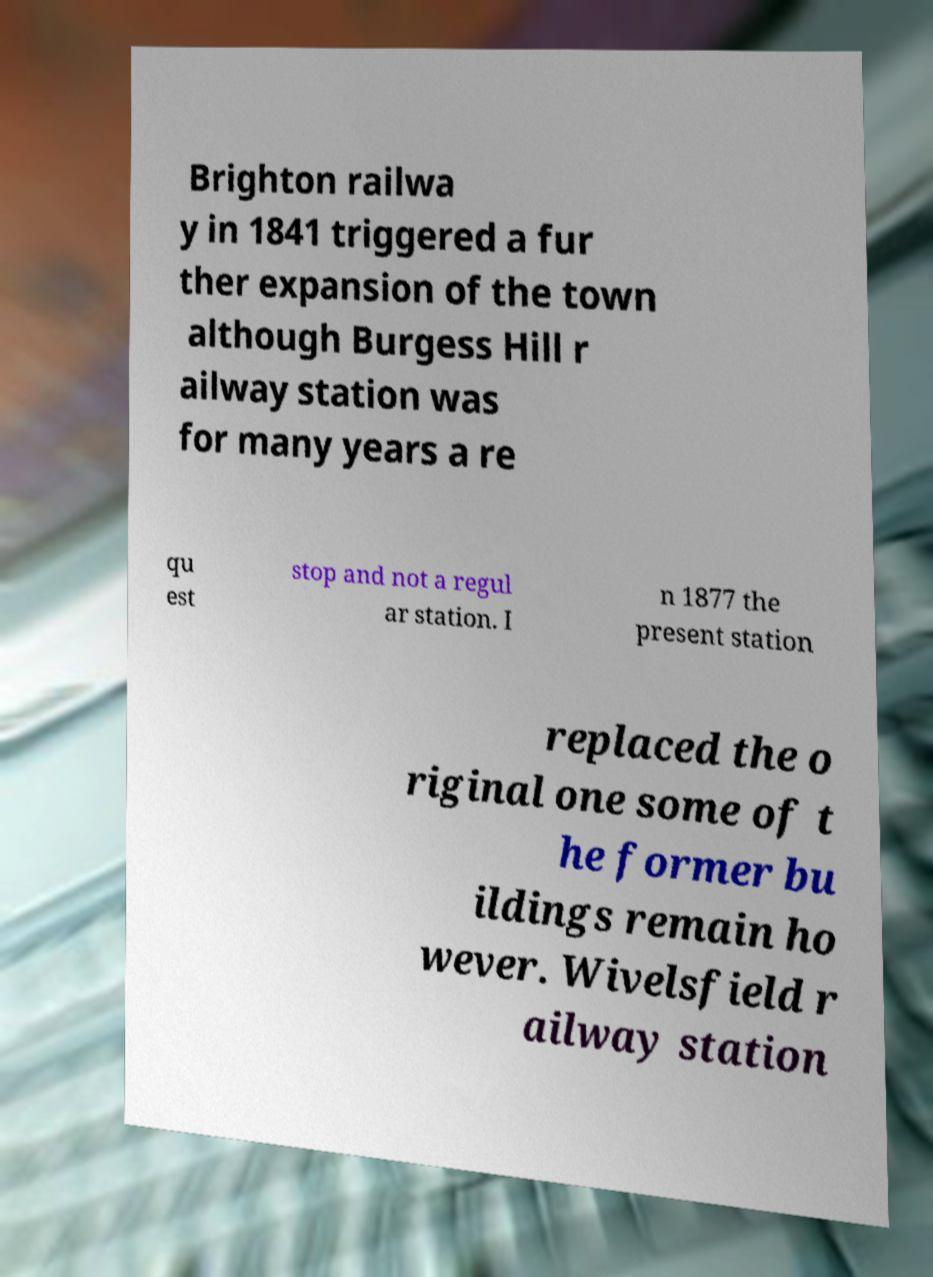Could you assist in decoding the text presented in this image and type it out clearly? Brighton railwa y in 1841 triggered a fur ther expansion of the town although Burgess Hill r ailway station was for many years a re qu est stop and not a regul ar station. I n 1877 the present station replaced the o riginal one some of t he former bu ildings remain ho wever. Wivelsfield r ailway station 